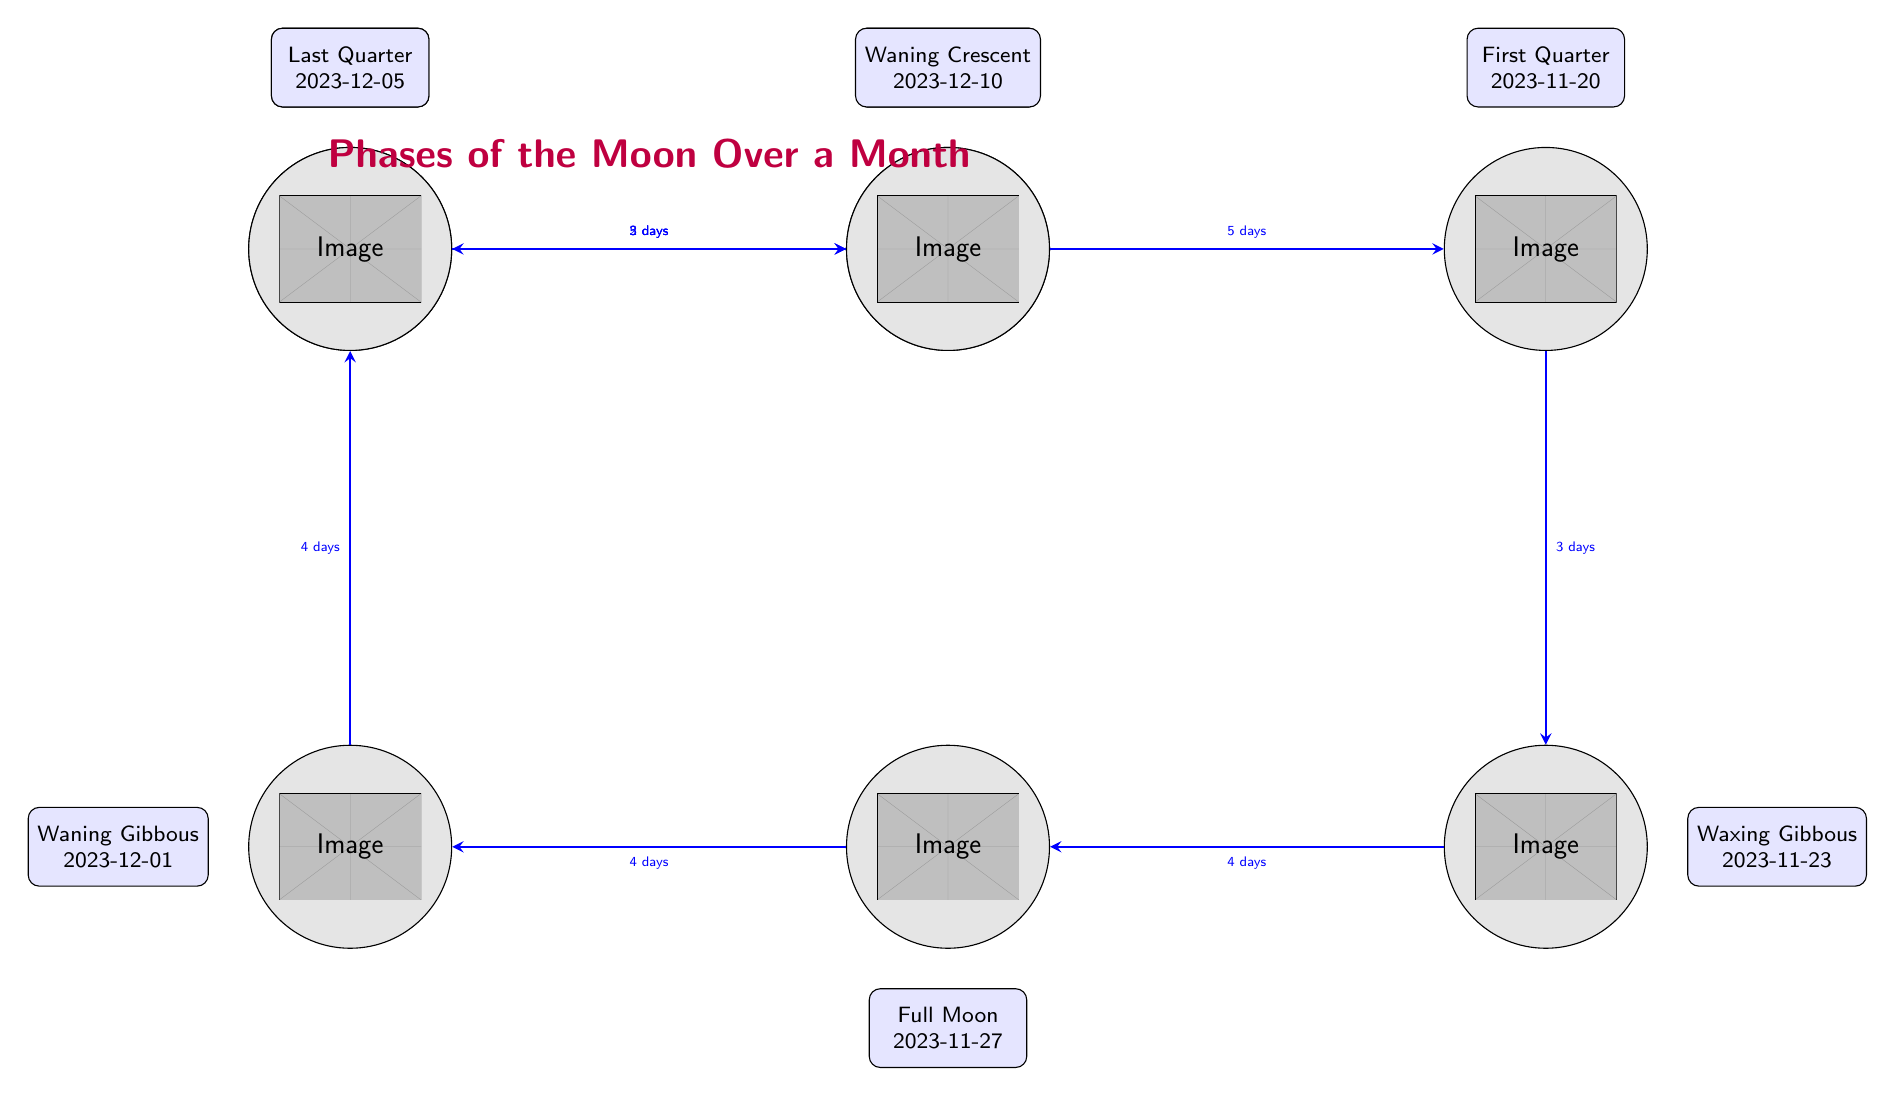What is the date of the Full Moon? The Full Moon is annotated as occurring on 2023-11-27, based on the event description connected to the Full Moon node in the diagram.
Answer: 2023-11-27 How many total phases are represented in the diagram? The diagram includes a total of eight lunar phases represented as nodes: New Moon, Waxing Crescent, First Quarter, Waxing Gibbous, Full Moon, Waning Gibbous, Last Quarter, and Waning Crescent.
Answer: 8 What is the next phase after the New Moon? The arrow connecting the New Moon node to the Waxing Crescent node indicates that the Waxing Crescent is the next phase after the New Moon.
Answer: Waxing Crescent How many days are there between the First Quarter and the Waxing Gibbous? An arrow from First Quarter to Waxing Gibbous shows the label “3 days,” indicating the duration between these two phases.
Answer: 3 days What is the transition duration from Full Moon to Waning Gibbous? The diagram shows an arrow from the Full Moon node to the Waning Gibbous node, labeled with "4 days," which indicates the duration of the transition.
Answer: 4 days Which phase occurs immediately before the New Moon? The arrow connecting the Waning Crescent to the New Moon indicates that the Waning Crescent is the phase that occurs immediately before the New Moon.
Answer: Waning Crescent Which lunar phase is associated with the date 2023-12-01? The event annotation connected to the Waning Gibbous node states that this phase occurs on 2023-12-01.
Answer: Waning Gibbous What is the total number of days from New Moon to Full Moon? The transitions are as follows: New Moon to Waxing Crescent (2 days) + Waxing Crescent to First Quarter (5 days) + First Quarter to Waxing Gibbous (3 days) + Waxing Gibbous to Full Moon (4 days), totaling 14 days.
Answer: 14 days What is the lunar phase following the Last Quarter? The arrow leading from the Last Quarter node to the Waning Crescent node indicates that the Waning Crescent is the subsequent phase.
Answer: Waning Crescent 